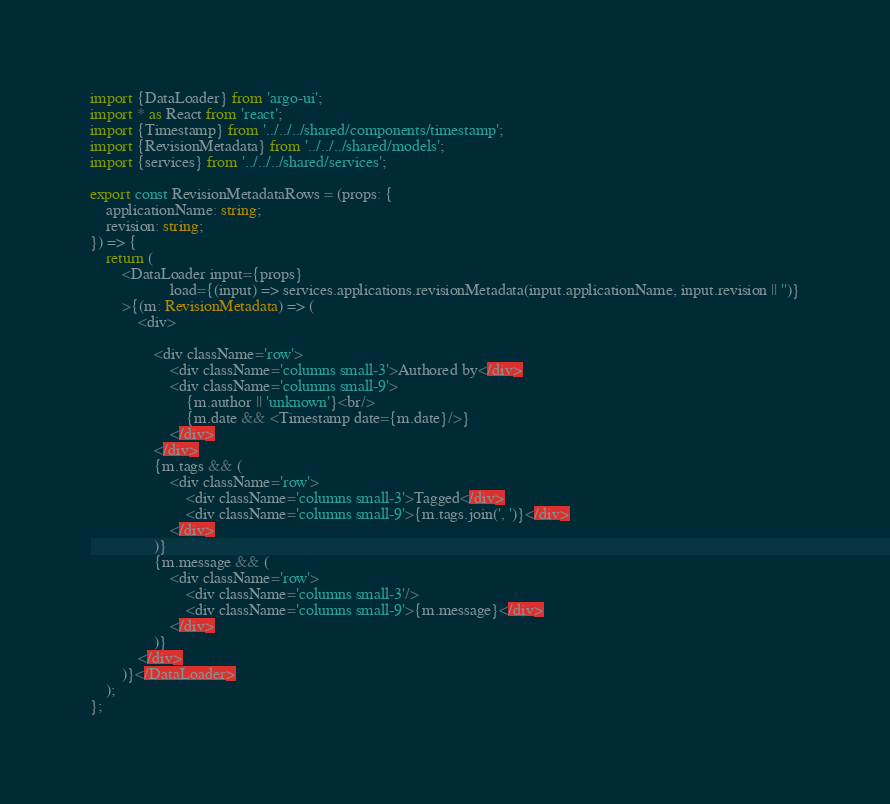<code> <loc_0><loc_0><loc_500><loc_500><_TypeScript_>import {DataLoader} from 'argo-ui';
import * as React from 'react';
import {Timestamp} from '../../../shared/components/timestamp';
import {RevisionMetadata} from '../../../shared/models';
import {services} from '../../../shared/services';

export const RevisionMetadataRows = (props: {
    applicationName: string;
    revision: string;
}) => {
    return (
        <DataLoader input={props}
                    load={(input) => services.applications.revisionMetadata(input.applicationName, input.revision || '')}
        >{(m: RevisionMetadata) => (
            <div>

                <div className='row'>
                    <div className='columns small-3'>Authored by</div>
                    <div className='columns small-9'>
                        {m.author || 'unknown'}<br/>
                        {m.date && <Timestamp date={m.date}/>}
                    </div>
                </div>
                {m.tags && (
                    <div className='row'>
                        <div className='columns small-3'>Tagged</div>
                        <div className='columns small-9'>{m.tags.join(', ')}</div>
                    </div>
                )}
                {m.message && (
                    <div className='row'>
                        <div className='columns small-3'/>
                        <div className='columns small-9'>{m.message}</div>
                    </div>
                )}
            </div>
        )}</DataLoader>
    );
};
</code> 